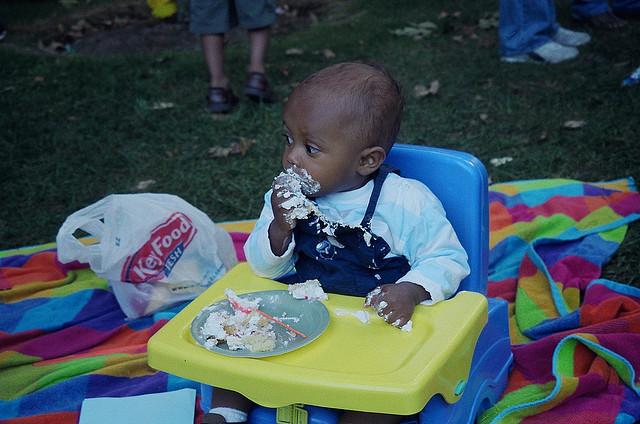Do the children have drinks?
Be succinct. No. Is the baby outside?
Keep it brief. Yes. What is the baby eating?
Give a very brief answer. Cake. What is on these boys faces?
Concise answer only. Cake. Is he using his fork?
Concise answer only. No. 